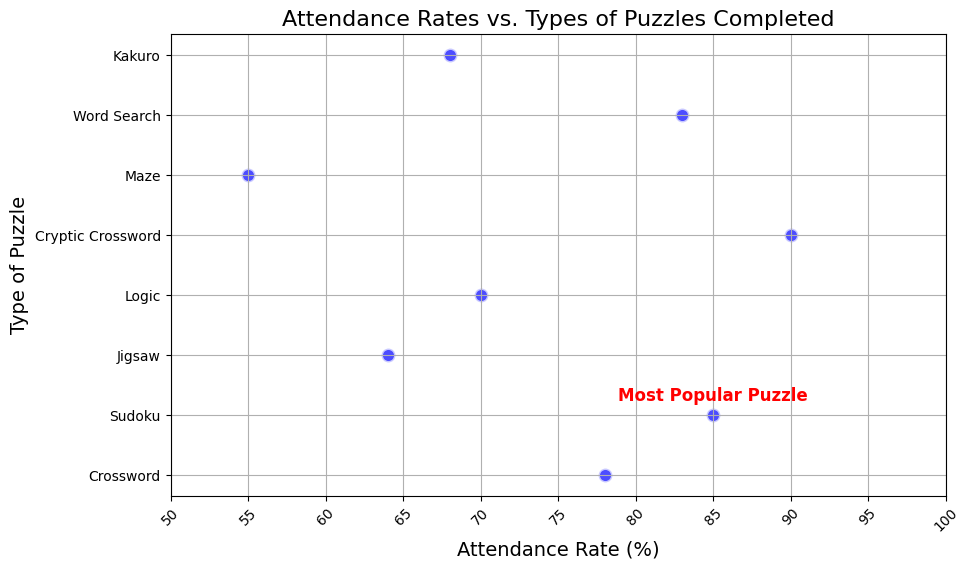What's the attendance rate for the puzzle type identified as the most popular? The text annotation specifies that Sudoku is the most popular puzzle. By looking at the y-axis label "Sudoku" and following it to its corresponding point on the x-axis, the attendance rate is 85%.
Answer: 85% Which type of puzzle is associated with the lowest attendance rate? The y-axis scales down from top to bottom. The lowest point on the x-axis, which corresponds with the label "55," is associated with "Maze," given the labels on the y-axis.
Answer: Maze How much greater is the attendance rate for Cryptic Crossword compared to Jigsaw? The attendance rate for Cryptic Crossword is 90%, and for Jigsaw, it is 64%. Calculate the difference: 90% - 64% = 26%.
Answer: 26% Which two puzzle types have attendance rates closest to each other, and what are their rates? By visually examining the plot, Sudoku (85%) and Word Search (83%) have the closest rates. The difference between them is minimal compared to other pairs.
Answer: Sudoku and Word Search; 85% and 83% What is the range of attendance rates among the puzzle types? The minimum attendance rate is 55% (Maze), and the maximum attendance rate is 90% (Cryptic Crossword). The range is calculated as 90% - 55% = 35%.
Answer: 35% How many puzzle types have an attendance rate above 75%? By visually examining the plot and comparing each point's x-coordinate to 75% on the x-axis, there are four puzzle types: Cryptic Crossword, Word Search, Sudoku, and Crossword.
Answer: 4 On average, what is the attendance rate for logic-based puzzles (Logic, Sudoku, Cryptic Crossword)? Summing the attendance rates for Logic (70%), Sudoku (85%), and Cryptic Crossword (90%) = 70 + 85 + 90 = 245. The average is 245 / 3 = 81.67%.
Answer: 81.67% Which puzzle type has the highest attendance rate excluding the most popular puzzle? The y-axis labels lead to the highest attendance rate, excluding Sudoku (most popular), which is 90% for Cryptic Crossword.
Answer: Cryptic Crossword 